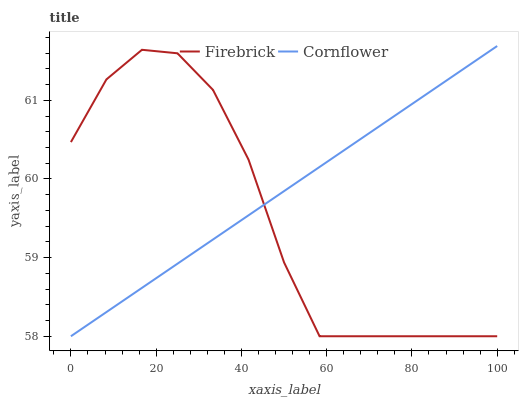Does Firebrick have the minimum area under the curve?
Answer yes or no. Yes. Does Cornflower have the maximum area under the curve?
Answer yes or no. Yes. Does Firebrick have the maximum area under the curve?
Answer yes or no. No. Is Cornflower the smoothest?
Answer yes or no. Yes. Is Firebrick the roughest?
Answer yes or no. Yes. Is Firebrick the smoothest?
Answer yes or no. No. Does Firebrick have the highest value?
Answer yes or no. No. 